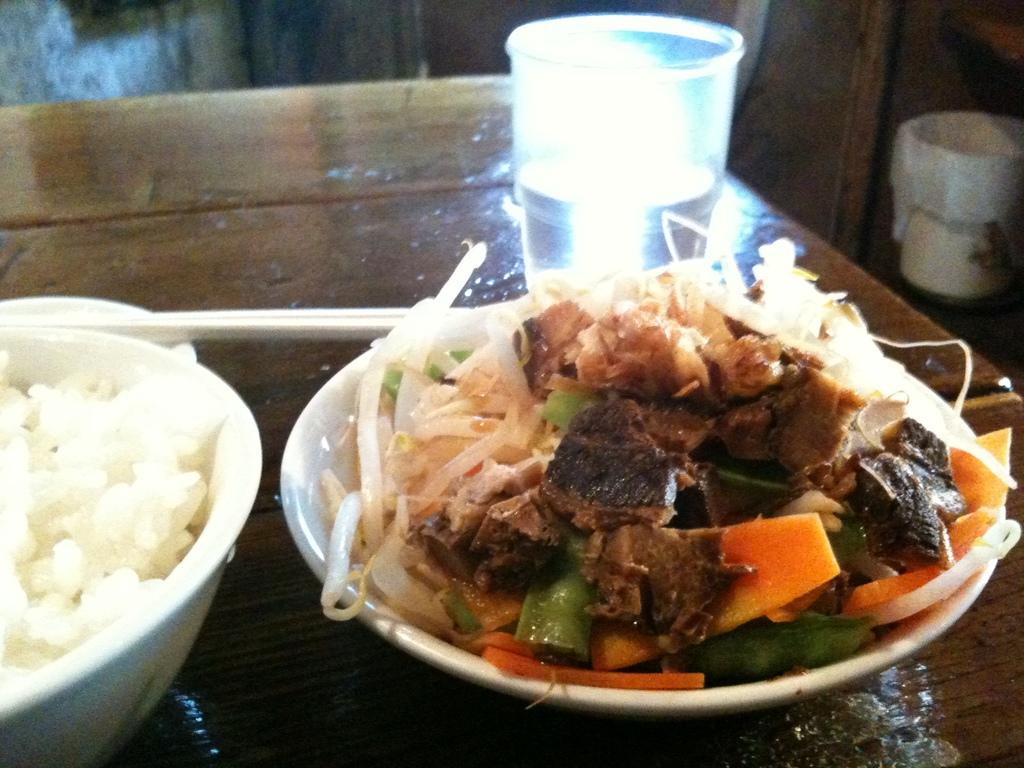What type of items can be seen in the image? There are eatables and a glass of water in the image. Where are the eatables and glass of water located? The glass of water and eatables are placed on a table. What type of arch can be seen in the image? There is no arch present in the image. What time does the clock show in the image? There is no clock present in the image. 